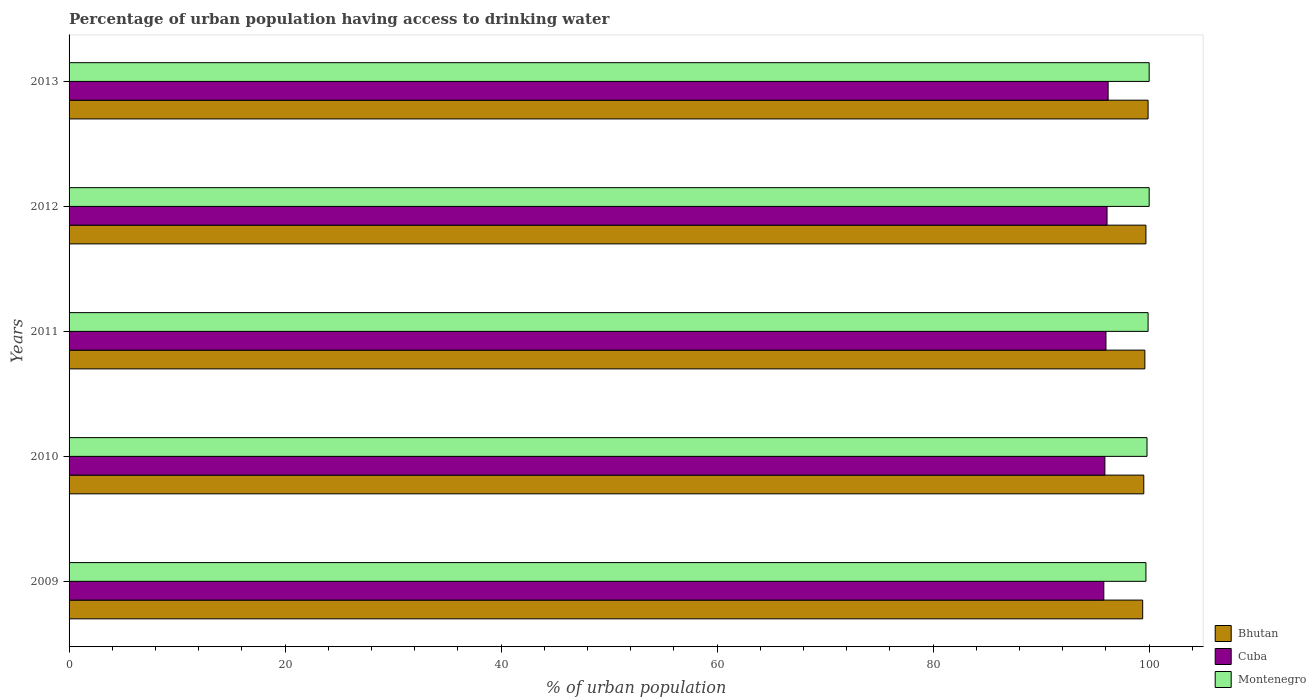How many different coloured bars are there?
Your answer should be very brief. 3. How many groups of bars are there?
Your response must be concise. 5. Are the number of bars per tick equal to the number of legend labels?
Provide a short and direct response. Yes. Are the number of bars on each tick of the Y-axis equal?
Your answer should be compact. Yes. How many bars are there on the 5th tick from the bottom?
Provide a short and direct response. 3. In how many cases, is the number of bars for a given year not equal to the number of legend labels?
Make the answer very short. 0. What is the percentage of urban population having access to drinking water in Bhutan in 2013?
Your response must be concise. 99.9. Across all years, what is the maximum percentage of urban population having access to drinking water in Bhutan?
Keep it short and to the point. 99.9. Across all years, what is the minimum percentage of urban population having access to drinking water in Bhutan?
Ensure brevity in your answer.  99.4. In which year was the percentage of urban population having access to drinking water in Bhutan maximum?
Offer a terse response. 2013. What is the total percentage of urban population having access to drinking water in Bhutan in the graph?
Offer a very short reply. 498.1. What is the difference between the percentage of urban population having access to drinking water in Bhutan in 2010 and that in 2013?
Ensure brevity in your answer.  -0.4. What is the average percentage of urban population having access to drinking water in Cuba per year?
Your answer should be compact. 96. In the year 2013, what is the difference between the percentage of urban population having access to drinking water in Montenegro and percentage of urban population having access to drinking water in Cuba?
Offer a terse response. 3.8. In how many years, is the percentage of urban population having access to drinking water in Montenegro greater than 8 %?
Your answer should be very brief. 5. What is the ratio of the percentage of urban population having access to drinking water in Bhutan in 2009 to that in 2011?
Your response must be concise. 1. Is the percentage of urban population having access to drinking water in Cuba in 2011 less than that in 2013?
Offer a terse response. Yes. What is the difference between the highest and the second highest percentage of urban population having access to drinking water in Bhutan?
Your answer should be compact. 0.2. What is the difference between the highest and the lowest percentage of urban population having access to drinking water in Cuba?
Provide a short and direct response. 0.4. Is the sum of the percentage of urban population having access to drinking water in Bhutan in 2010 and 2011 greater than the maximum percentage of urban population having access to drinking water in Cuba across all years?
Keep it short and to the point. Yes. What does the 3rd bar from the top in 2012 represents?
Your response must be concise. Bhutan. What does the 3rd bar from the bottom in 2013 represents?
Make the answer very short. Montenegro. How many bars are there?
Give a very brief answer. 15. How many years are there in the graph?
Keep it short and to the point. 5. Does the graph contain any zero values?
Offer a very short reply. No. Does the graph contain grids?
Offer a terse response. No. How are the legend labels stacked?
Offer a terse response. Vertical. What is the title of the graph?
Keep it short and to the point. Percentage of urban population having access to drinking water. What is the label or title of the X-axis?
Ensure brevity in your answer.  % of urban population. What is the % of urban population in Bhutan in 2009?
Make the answer very short. 99.4. What is the % of urban population of Cuba in 2009?
Your answer should be very brief. 95.8. What is the % of urban population in Montenegro in 2009?
Ensure brevity in your answer.  99.7. What is the % of urban population in Bhutan in 2010?
Provide a short and direct response. 99.5. What is the % of urban population in Cuba in 2010?
Your response must be concise. 95.9. What is the % of urban population in Montenegro in 2010?
Your response must be concise. 99.8. What is the % of urban population in Bhutan in 2011?
Your answer should be very brief. 99.6. What is the % of urban population in Cuba in 2011?
Give a very brief answer. 96. What is the % of urban population in Montenegro in 2011?
Your response must be concise. 99.9. What is the % of urban population in Bhutan in 2012?
Ensure brevity in your answer.  99.7. What is the % of urban population of Cuba in 2012?
Your answer should be compact. 96.1. What is the % of urban population in Bhutan in 2013?
Provide a succinct answer. 99.9. What is the % of urban population of Cuba in 2013?
Keep it short and to the point. 96.2. Across all years, what is the maximum % of urban population in Bhutan?
Offer a very short reply. 99.9. Across all years, what is the maximum % of urban population in Cuba?
Give a very brief answer. 96.2. Across all years, what is the maximum % of urban population of Montenegro?
Keep it short and to the point. 100. Across all years, what is the minimum % of urban population of Bhutan?
Your answer should be compact. 99.4. Across all years, what is the minimum % of urban population in Cuba?
Make the answer very short. 95.8. Across all years, what is the minimum % of urban population of Montenegro?
Your answer should be compact. 99.7. What is the total % of urban population in Bhutan in the graph?
Your answer should be compact. 498.1. What is the total % of urban population of Cuba in the graph?
Offer a terse response. 480. What is the total % of urban population of Montenegro in the graph?
Provide a succinct answer. 499.4. What is the difference between the % of urban population of Bhutan in 2009 and that in 2010?
Make the answer very short. -0.1. What is the difference between the % of urban population in Montenegro in 2009 and that in 2011?
Offer a very short reply. -0.2. What is the difference between the % of urban population of Bhutan in 2009 and that in 2012?
Keep it short and to the point. -0.3. What is the difference between the % of urban population in Cuba in 2009 and that in 2012?
Your response must be concise. -0.3. What is the difference between the % of urban population of Montenegro in 2009 and that in 2012?
Ensure brevity in your answer.  -0.3. What is the difference between the % of urban population in Montenegro in 2009 and that in 2013?
Offer a terse response. -0.3. What is the difference between the % of urban population of Bhutan in 2010 and that in 2011?
Offer a very short reply. -0.1. What is the difference between the % of urban population in Cuba in 2010 and that in 2012?
Ensure brevity in your answer.  -0.2. What is the difference between the % of urban population of Cuba in 2010 and that in 2013?
Your answer should be very brief. -0.3. What is the difference between the % of urban population of Cuba in 2011 and that in 2013?
Your response must be concise. -0.2. What is the difference between the % of urban population of Bhutan in 2012 and that in 2013?
Ensure brevity in your answer.  -0.2. What is the difference between the % of urban population of Cuba in 2012 and that in 2013?
Make the answer very short. -0.1. What is the difference between the % of urban population in Montenegro in 2012 and that in 2013?
Give a very brief answer. 0. What is the difference between the % of urban population in Bhutan in 2009 and the % of urban population in Montenegro in 2010?
Your answer should be very brief. -0.4. What is the difference between the % of urban population in Cuba in 2009 and the % of urban population in Montenegro in 2011?
Offer a very short reply. -4.1. What is the difference between the % of urban population of Bhutan in 2009 and the % of urban population of Cuba in 2012?
Offer a very short reply. 3.3. What is the difference between the % of urban population of Bhutan in 2009 and the % of urban population of Montenegro in 2012?
Your answer should be compact. -0.6. What is the difference between the % of urban population of Bhutan in 2009 and the % of urban population of Cuba in 2013?
Offer a terse response. 3.2. What is the difference between the % of urban population in Bhutan in 2009 and the % of urban population in Montenegro in 2013?
Offer a terse response. -0.6. What is the difference between the % of urban population in Bhutan in 2010 and the % of urban population in Montenegro in 2011?
Your answer should be compact. -0.4. What is the difference between the % of urban population in Cuba in 2010 and the % of urban population in Montenegro in 2012?
Offer a very short reply. -4.1. What is the difference between the % of urban population of Bhutan in 2010 and the % of urban population of Montenegro in 2013?
Your response must be concise. -0.5. What is the difference between the % of urban population of Cuba in 2010 and the % of urban population of Montenegro in 2013?
Make the answer very short. -4.1. What is the difference between the % of urban population in Bhutan in 2011 and the % of urban population in Montenegro in 2012?
Offer a very short reply. -0.4. What is the difference between the % of urban population in Cuba in 2011 and the % of urban population in Montenegro in 2013?
Give a very brief answer. -4. What is the difference between the % of urban population in Bhutan in 2012 and the % of urban population in Cuba in 2013?
Provide a succinct answer. 3.5. What is the difference between the % of urban population in Bhutan in 2012 and the % of urban population in Montenegro in 2013?
Keep it short and to the point. -0.3. What is the difference between the % of urban population of Cuba in 2012 and the % of urban population of Montenegro in 2013?
Ensure brevity in your answer.  -3.9. What is the average % of urban population in Bhutan per year?
Make the answer very short. 99.62. What is the average % of urban population of Cuba per year?
Your answer should be compact. 96. What is the average % of urban population in Montenegro per year?
Keep it short and to the point. 99.88. In the year 2010, what is the difference between the % of urban population of Bhutan and % of urban population of Cuba?
Ensure brevity in your answer.  3.6. In the year 2010, what is the difference between the % of urban population in Bhutan and % of urban population in Montenegro?
Offer a very short reply. -0.3. In the year 2011, what is the difference between the % of urban population in Bhutan and % of urban population in Montenegro?
Ensure brevity in your answer.  -0.3. In the year 2012, what is the difference between the % of urban population of Bhutan and % of urban population of Cuba?
Provide a short and direct response. 3.6. In the year 2012, what is the difference between the % of urban population in Cuba and % of urban population in Montenegro?
Provide a succinct answer. -3.9. In the year 2013, what is the difference between the % of urban population of Bhutan and % of urban population of Cuba?
Your answer should be very brief. 3.7. What is the ratio of the % of urban population in Bhutan in 2009 to that in 2010?
Ensure brevity in your answer.  1. What is the ratio of the % of urban population of Cuba in 2009 to that in 2010?
Offer a very short reply. 1. What is the ratio of the % of urban population in Montenegro in 2009 to that in 2010?
Your response must be concise. 1. What is the ratio of the % of urban population in Montenegro in 2009 to that in 2011?
Offer a terse response. 1. What is the ratio of the % of urban population in Cuba in 2009 to that in 2013?
Your response must be concise. 1. What is the ratio of the % of urban population of Bhutan in 2010 to that in 2012?
Offer a very short reply. 1. What is the ratio of the % of urban population in Cuba in 2010 to that in 2012?
Your answer should be compact. 1. What is the ratio of the % of urban population of Bhutan in 2010 to that in 2013?
Offer a terse response. 1. What is the ratio of the % of urban population of Montenegro in 2010 to that in 2013?
Provide a succinct answer. 1. What is the ratio of the % of urban population in Bhutan in 2011 to that in 2013?
Make the answer very short. 1. What is the ratio of the % of urban population of Montenegro in 2011 to that in 2013?
Offer a very short reply. 1. What is the ratio of the % of urban population of Bhutan in 2012 to that in 2013?
Your response must be concise. 1. What is the ratio of the % of urban population of Cuba in 2012 to that in 2013?
Give a very brief answer. 1. What is the ratio of the % of urban population of Montenegro in 2012 to that in 2013?
Your answer should be very brief. 1. What is the difference between the highest and the second highest % of urban population in Bhutan?
Your answer should be compact. 0.2. What is the difference between the highest and the second highest % of urban population in Montenegro?
Your response must be concise. 0. 